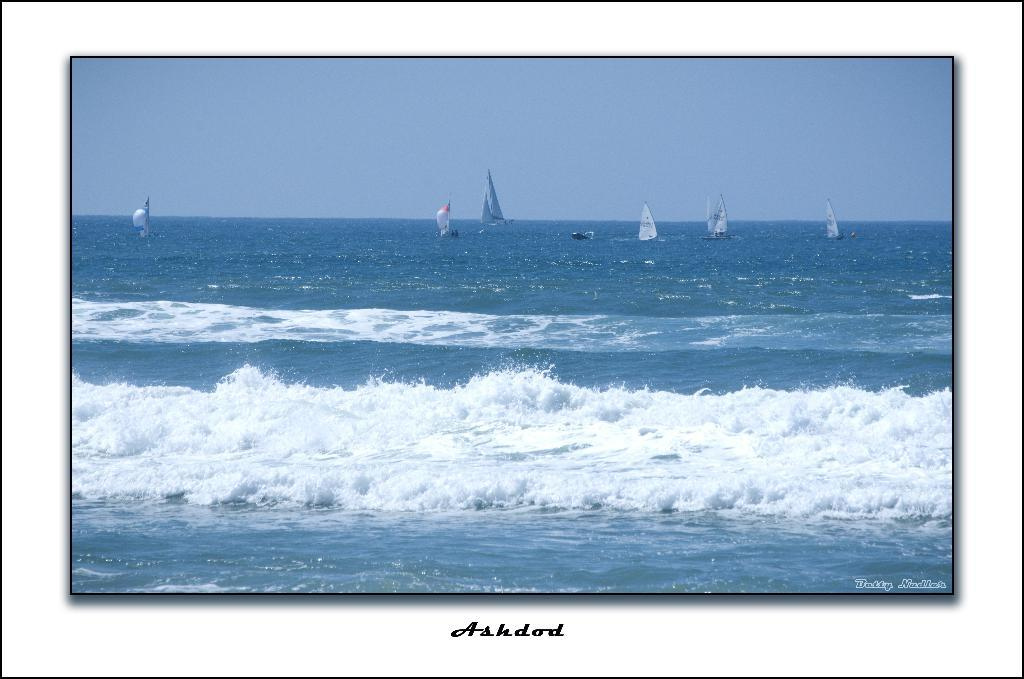What is the primary element in the image? There is water in the image. What is floating on the water? There are boats on the water. What can be seen above the water in the image? The sky is visible at the top of the image. What is the condition of the water's surface? Waves are present in the water. What additional information is provided below the image? There is text below the image. What type of muscle is being exercised by the person in the image? There is no person present in the image, so it is not possible to determine which muscle is being exercised. 